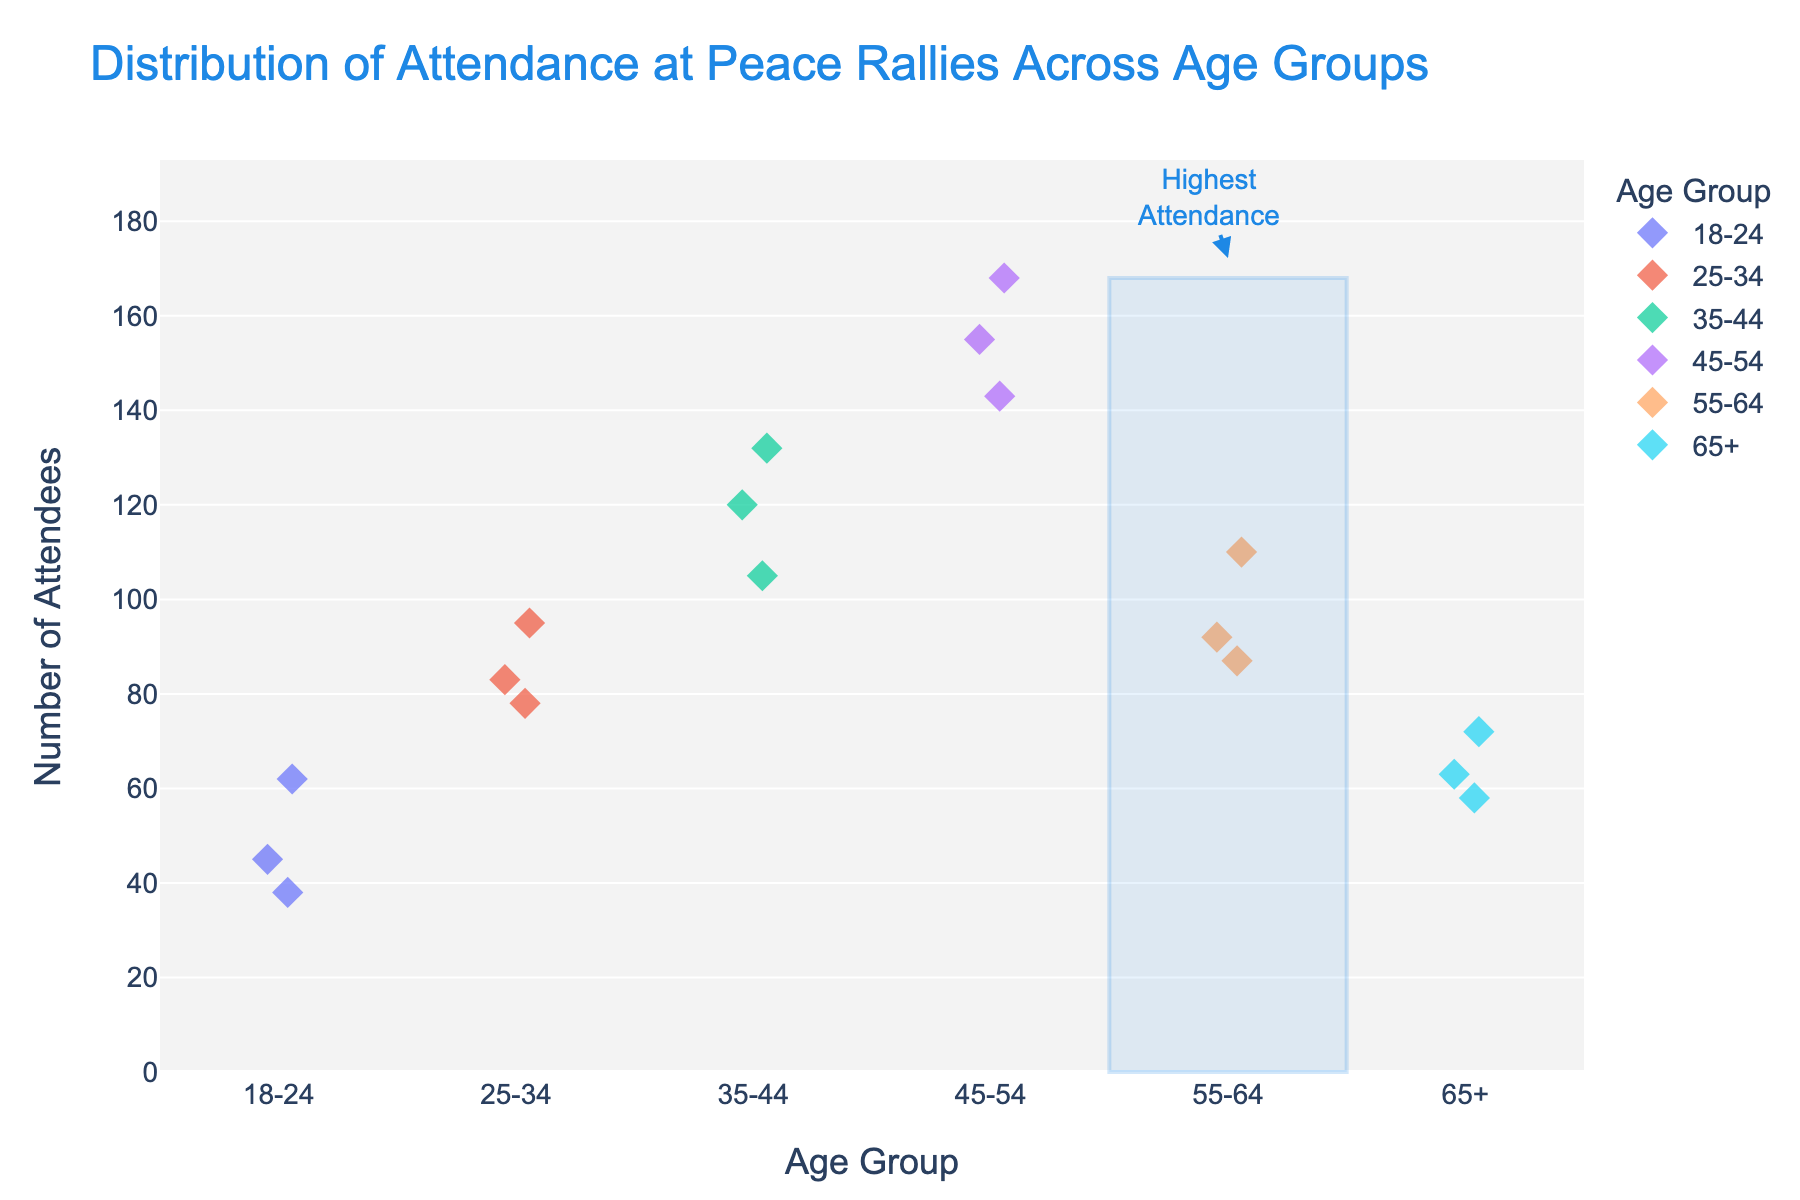What's the title of the figure? Look at the top of the figure where the main heading is displayed, which represents the main subject of the figure.
Answer: Distribution of Attendance at Peace Rallies Across Age Groups How many data points are there for the age group 35-44? Count the number of diamond markers in the strip plot under the age group 35-44.
Answer: 3 Which age group has the highest attendance at peace rallies? Observe the vertical position of the diamond markers. The group with the diamond markers at the highest position has the highest attendance, and also refer to the annotation box.
Answer: 45-54 What is the range of attendance for the age group 25-34? Identify the highest and lowest data points within the strip plot for the age group 25-34, and calculate the difference between them. 95 (max) - 78 (min) = 17.
Answer: 17 Which age group has the least variability in attendance? Compare the spread (distribution) of data points for each age group. The group with the least spread (most clustered data points) has the least variability.
Answer: 65+ What is the average attendance for the age group 18-24? Add the attendance values for 18-24: 45 + 62 + 38 = 145. Divide by the number of data points (3). 145 / 3 = 48.3.
Answer: 48.3 Is the attendance more consistent in the age group 55-64 or 35-44? Assess the spread of markers in these two groups. The group with markers closer together and less spread out has more consistent attendance.
Answer: 55-64 How does the attendance pattern for the age group 65+ compare to the age group 45-54? Compare the distribution of attendance values between the two age groups. The 65+ group has lower and less variable attendance compared to the 45-54 group which has higher and more variable attendance.
Answer: 65+ is lower and less variable What is the median attendance for the age group 55-64? List out the attendance values (87, 92, 110) in ascending order. The median value is the middle one.
Answer: 92 Which age group has a higher lower bound of attendance: 25-34 or 55-64? Compare the lowest attendance values for each group: 25-34 has a minimum of 78, and 55-64 has a minimum of 87.
Answer: 55-64 